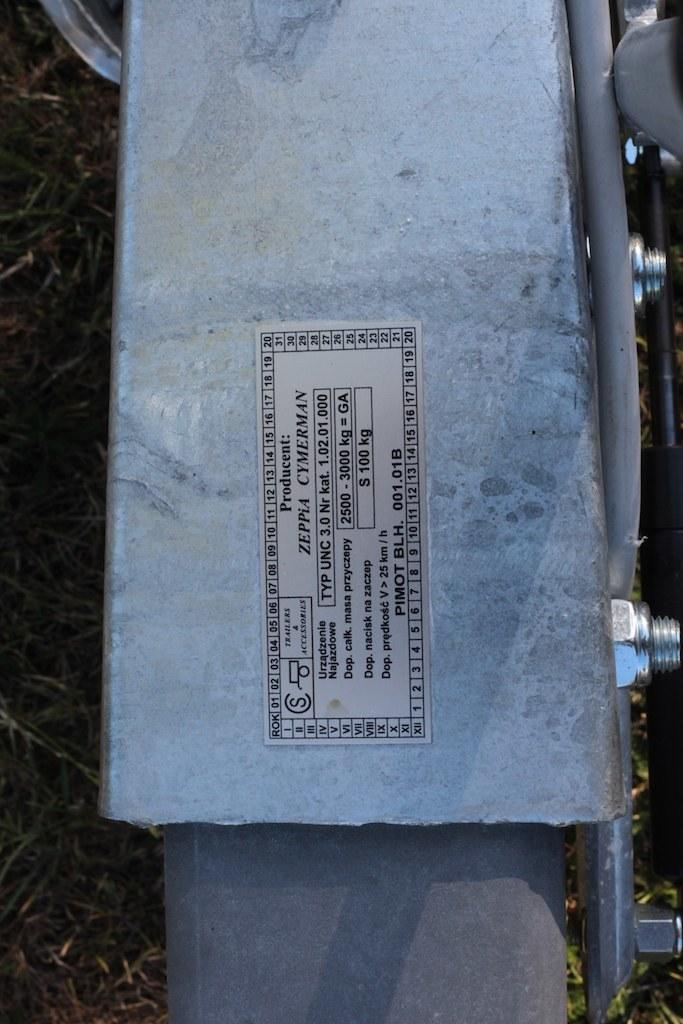What is on the platform in the image? There is a sticker on a platform in the image. What type of fasteners can be seen in the image? There are screws in the image. What object is present that is long and cylindrical? There is a rod in the image. What type of natural environment is visible in the background of the image? There is grass visible in the background of the image. How many rings are being worn by the person in the image? There is no person present in the image, so it is not possible to determine if anyone is wearing rings. 